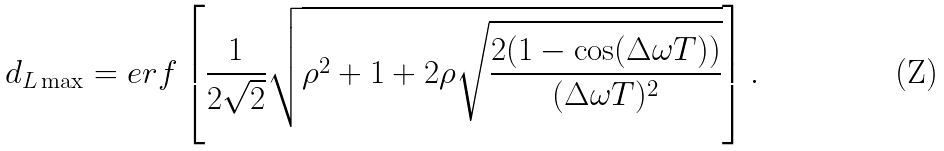Convert formula to latex. <formula><loc_0><loc_0><loc_500><loc_500>d _ { L \max } = e r f \left [ \frac { 1 } { 2 \sqrt { 2 } } \sqrt { \rho ^ { 2 } + 1 + 2 \rho \sqrt { \frac { 2 ( 1 - \cos ( \Delta \omega T ) ) } { ( \Delta \omega T ) ^ { 2 } } } } \right ] .</formula> 